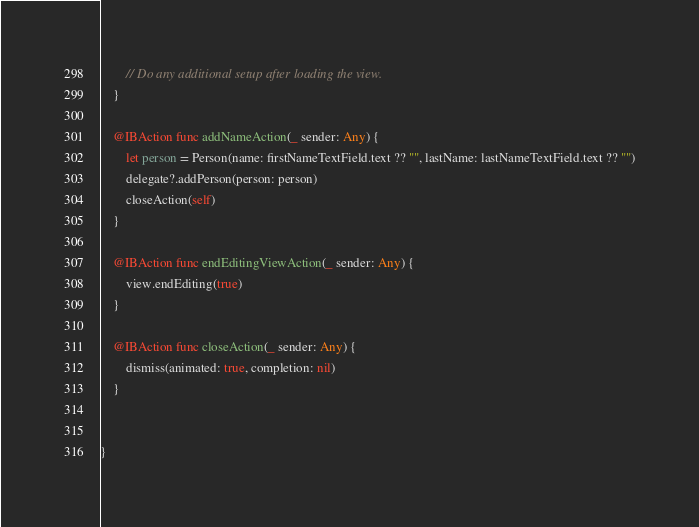<code> <loc_0><loc_0><loc_500><loc_500><_Swift_>        // Do any additional setup after loading the view.
    }
    
    @IBAction func addNameAction(_ sender: Any) {
        let person = Person(name: firstNameTextField.text ?? "", lastName: lastNameTextField.text ?? "")
        delegate?.addPerson(person: person)
        closeAction(self)
    }
    
    @IBAction func endEditingViewAction(_ sender: Any) {
        view.endEditing(true)
    }
    
    @IBAction func closeAction(_ sender: Any) {
        dismiss(animated: true, completion: nil)
    }
    
    
}
</code> 